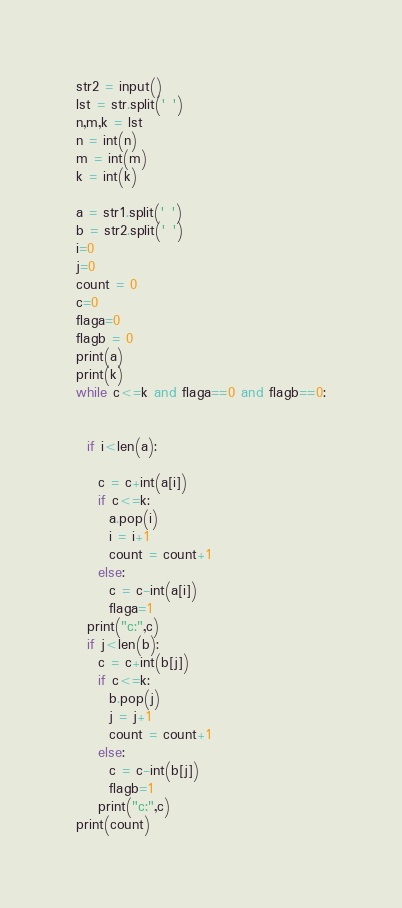<code> <loc_0><loc_0><loc_500><loc_500><_Python_>str2 = input()
lst = str.split(' ')
n,m,k = lst
n = int(n)
m = int(m)
k = int(k)

a = str1.split(' ')
b = str2.split(' ')
i=0
j=0
count = 0
c=0
flaga=0
flagb = 0
print(a)
print(k)
while c<=k and flaga==0 and flagb==0:
  
  
  if i<len(a):
    
    c = c+int(a[i])
    if c<=k:
      a.pop(i)
      i = i+1
      count = count+1
    else:
      c = c-int(a[i])
      flaga=1
  print("c:",c)
  if j<len(b):
    c = c+int(b[j])
    if c<=k:
      b.pop(j)
      j = j+1
      count = count+1
    else:
      c = c-int(b[j])
      flagb=1
    print("c:",c)
print(count)
</code> 